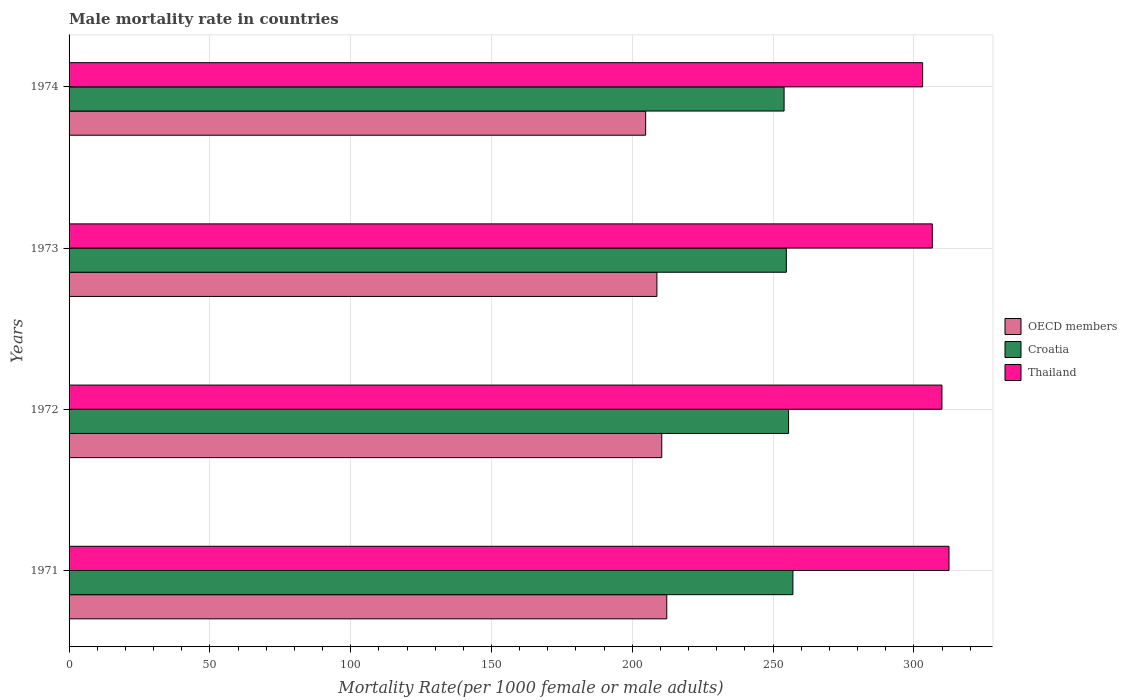How many different coloured bars are there?
Give a very brief answer. 3. Are the number of bars per tick equal to the number of legend labels?
Offer a terse response. Yes. What is the label of the 2nd group of bars from the top?
Your answer should be very brief. 1973. In how many cases, is the number of bars for a given year not equal to the number of legend labels?
Give a very brief answer. 0. What is the male mortality rate in OECD members in 1972?
Your answer should be very brief. 210.46. Across all years, what is the maximum male mortality rate in OECD members?
Keep it short and to the point. 212.24. Across all years, what is the minimum male mortality rate in Croatia?
Make the answer very short. 253.9. In which year was the male mortality rate in OECD members maximum?
Make the answer very short. 1971. In which year was the male mortality rate in OECD members minimum?
Offer a very short reply. 1974. What is the total male mortality rate in Croatia in the graph?
Your response must be concise. 1021.13. What is the difference between the male mortality rate in Croatia in 1973 and that in 1974?
Offer a terse response. 0.8. What is the difference between the male mortality rate in Croatia in 1974 and the male mortality rate in OECD members in 1972?
Provide a succinct answer. 43.44. What is the average male mortality rate in Croatia per year?
Your response must be concise. 255.28. In the year 1971, what is the difference between the male mortality rate in Thailand and male mortality rate in Croatia?
Keep it short and to the point. 55.42. In how many years, is the male mortality rate in Croatia greater than 90 ?
Ensure brevity in your answer.  4. What is the ratio of the male mortality rate in OECD members in 1972 to that in 1973?
Ensure brevity in your answer.  1.01. What is the difference between the highest and the second highest male mortality rate in OECD members?
Make the answer very short. 1.78. What is the difference between the highest and the lowest male mortality rate in OECD members?
Provide a short and direct response. 7.5. In how many years, is the male mortality rate in OECD members greater than the average male mortality rate in OECD members taken over all years?
Your response must be concise. 2. What does the 2nd bar from the top in 1974 represents?
Make the answer very short. Croatia. What does the 1st bar from the bottom in 1972 represents?
Offer a very short reply. OECD members. Are all the bars in the graph horizontal?
Provide a succinct answer. Yes. How many years are there in the graph?
Provide a succinct answer. 4. Are the values on the major ticks of X-axis written in scientific E-notation?
Provide a short and direct response. No. Where does the legend appear in the graph?
Your answer should be compact. Center right. How many legend labels are there?
Provide a succinct answer. 3. How are the legend labels stacked?
Give a very brief answer. Vertical. What is the title of the graph?
Offer a terse response. Male mortality rate in countries. What is the label or title of the X-axis?
Your answer should be compact. Mortality Rate(per 1000 female or male adults). What is the label or title of the Y-axis?
Offer a terse response. Years. What is the Mortality Rate(per 1000 female or male adults) of OECD members in 1971?
Your answer should be compact. 212.24. What is the Mortality Rate(per 1000 female or male adults) in Croatia in 1971?
Your response must be concise. 257.03. What is the Mortality Rate(per 1000 female or male adults) in Thailand in 1971?
Offer a very short reply. 312.46. What is the Mortality Rate(per 1000 female or male adults) of OECD members in 1972?
Make the answer very short. 210.46. What is the Mortality Rate(per 1000 female or male adults) of Croatia in 1972?
Your response must be concise. 255.5. What is the Mortality Rate(per 1000 female or male adults) of Thailand in 1972?
Provide a short and direct response. 309.95. What is the Mortality Rate(per 1000 female or male adults) of OECD members in 1973?
Offer a terse response. 208.74. What is the Mortality Rate(per 1000 female or male adults) of Croatia in 1973?
Make the answer very short. 254.7. What is the Mortality Rate(per 1000 female or male adults) in Thailand in 1973?
Provide a short and direct response. 306.52. What is the Mortality Rate(per 1000 female or male adults) in OECD members in 1974?
Provide a succinct answer. 204.74. What is the Mortality Rate(per 1000 female or male adults) in Croatia in 1974?
Offer a very short reply. 253.9. What is the Mortality Rate(per 1000 female or male adults) in Thailand in 1974?
Your response must be concise. 303.09. Across all years, what is the maximum Mortality Rate(per 1000 female or male adults) in OECD members?
Ensure brevity in your answer.  212.24. Across all years, what is the maximum Mortality Rate(per 1000 female or male adults) of Croatia?
Your response must be concise. 257.03. Across all years, what is the maximum Mortality Rate(per 1000 female or male adults) in Thailand?
Make the answer very short. 312.46. Across all years, what is the minimum Mortality Rate(per 1000 female or male adults) of OECD members?
Ensure brevity in your answer.  204.74. Across all years, what is the minimum Mortality Rate(per 1000 female or male adults) in Croatia?
Ensure brevity in your answer.  253.9. Across all years, what is the minimum Mortality Rate(per 1000 female or male adults) in Thailand?
Provide a short and direct response. 303.09. What is the total Mortality Rate(per 1000 female or male adults) of OECD members in the graph?
Offer a very short reply. 836.18. What is the total Mortality Rate(per 1000 female or male adults) in Croatia in the graph?
Ensure brevity in your answer.  1021.13. What is the total Mortality Rate(per 1000 female or male adults) of Thailand in the graph?
Make the answer very short. 1232.01. What is the difference between the Mortality Rate(per 1000 female or male adults) in OECD members in 1971 and that in 1972?
Give a very brief answer. 1.78. What is the difference between the Mortality Rate(per 1000 female or male adults) of Croatia in 1971 and that in 1972?
Give a very brief answer. 1.54. What is the difference between the Mortality Rate(per 1000 female or male adults) in Thailand in 1971 and that in 1972?
Ensure brevity in your answer.  2.51. What is the difference between the Mortality Rate(per 1000 female or male adults) of OECD members in 1971 and that in 1973?
Your response must be concise. 3.5. What is the difference between the Mortality Rate(per 1000 female or male adults) of Croatia in 1971 and that in 1973?
Your answer should be very brief. 2.34. What is the difference between the Mortality Rate(per 1000 female or male adults) in Thailand in 1971 and that in 1973?
Provide a short and direct response. 5.94. What is the difference between the Mortality Rate(per 1000 female or male adults) of OECD members in 1971 and that in 1974?
Your answer should be compact. 7.5. What is the difference between the Mortality Rate(per 1000 female or male adults) of Croatia in 1971 and that in 1974?
Your answer should be very brief. 3.13. What is the difference between the Mortality Rate(per 1000 female or male adults) of Thailand in 1971 and that in 1974?
Provide a short and direct response. 9.37. What is the difference between the Mortality Rate(per 1000 female or male adults) of OECD members in 1972 and that in 1973?
Provide a succinct answer. 1.72. What is the difference between the Mortality Rate(per 1000 female or male adults) in Croatia in 1972 and that in 1973?
Keep it short and to the point. 0.8. What is the difference between the Mortality Rate(per 1000 female or male adults) of Thailand in 1972 and that in 1973?
Provide a succinct answer. 3.43. What is the difference between the Mortality Rate(per 1000 female or male adults) of OECD members in 1972 and that in 1974?
Your response must be concise. 5.72. What is the difference between the Mortality Rate(per 1000 female or male adults) of Croatia in 1972 and that in 1974?
Your answer should be very brief. 1.59. What is the difference between the Mortality Rate(per 1000 female or male adults) of Thailand in 1972 and that in 1974?
Your response must be concise. 6.86. What is the difference between the Mortality Rate(per 1000 female or male adults) in OECD members in 1973 and that in 1974?
Give a very brief answer. 4. What is the difference between the Mortality Rate(per 1000 female or male adults) in Croatia in 1973 and that in 1974?
Make the answer very short. 0.8. What is the difference between the Mortality Rate(per 1000 female or male adults) of Thailand in 1973 and that in 1974?
Your response must be concise. 3.43. What is the difference between the Mortality Rate(per 1000 female or male adults) in OECD members in 1971 and the Mortality Rate(per 1000 female or male adults) in Croatia in 1972?
Provide a short and direct response. -43.25. What is the difference between the Mortality Rate(per 1000 female or male adults) in OECD members in 1971 and the Mortality Rate(per 1000 female or male adults) in Thailand in 1972?
Make the answer very short. -97.7. What is the difference between the Mortality Rate(per 1000 female or male adults) of Croatia in 1971 and the Mortality Rate(per 1000 female or male adults) of Thailand in 1972?
Provide a succinct answer. -52.91. What is the difference between the Mortality Rate(per 1000 female or male adults) in OECD members in 1971 and the Mortality Rate(per 1000 female or male adults) in Croatia in 1973?
Offer a terse response. -42.46. What is the difference between the Mortality Rate(per 1000 female or male adults) in OECD members in 1971 and the Mortality Rate(per 1000 female or male adults) in Thailand in 1973?
Offer a terse response. -94.28. What is the difference between the Mortality Rate(per 1000 female or male adults) of Croatia in 1971 and the Mortality Rate(per 1000 female or male adults) of Thailand in 1973?
Your answer should be very brief. -49.48. What is the difference between the Mortality Rate(per 1000 female or male adults) in OECD members in 1971 and the Mortality Rate(per 1000 female or male adults) in Croatia in 1974?
Give a very brief answer. -41.66. What is the difference between the Mortality Rate(per 1000 female or male adults) in OECD members in 1971 and the Mortality Rate(per 1000 female or male adults) in Thailand in 1974?
Keep it short and to the point. -90.85. What is the difference between the Mortality Rate(per 1000 female or male adults) in Croatia in 1971 and the Mortality Rate(per 1000 female or male adults) in Thailand in 1974?
Provide a short and direct response. -46.06. What is the difference between the Mortality Rate(per 1000 female or male adults) of OECD members in 1972 and the Mortality Rate(per 1000 female or male adults) of Croatia in 1973?
Give a very brief answer. -44.24. What is the difference between the Mortality Rate(per 1000 female or male adults) in OECD members in 1972 and the Mortality Rate(per 1000 female or male adults) in Thailand in 1973?
Make the answer very short. -96.06. What is the difference between the Mortality Rate(per 1000 female or male adults) of Croatia in 1972 and the Mortality Rate(per 1000 female or male adults) of Thailand in 1973?
Ensure brevity in your answer.  -51.02. What is the difference between the Mortality Rate(per 1000 female or male adults) of OECD members in 1972 and the Mortality Rate(per 1000 female or male adults) of Croatia in 1974?
Your answer should be compact. -43.44. What is the difference between the Mortality Rate(per 1000 female or male adults) in OECD members in 1972 and the Mortality Rate(per 1000 female or male adults) in Thailand in 1974?
Your answer should be compact. -92.63. What is the difference between the Mortality Rate(per 1000 female or male adults) in Croatia in 1972 and the Mortality Rate(per 1000 female or male adults) in Thailand in 1974?
Make the answer very short. -47.59. What is the difference between the Mortality Rate(per 1000 female or male adults) of OECD members in 1973 and the Mortality Rate(per 1000 female or male adults) of Croatia in 1974?
Offer a very short reply. -45.16. What is the difference between the Mortality Rate(per 1000 female or male adults) in OECD members in 1973 and the Mortality Rate(per 1000 female or male adults) in Thailand in 1974?
Your answer should be very brief. -94.35. What is the difference between the Mortality Rate(per 1000 female or male adults) of Croatia in 1973 and the Mortality Rate(per 1000 female or male adults) of Thailand in 1974?
Keep it short and to the point. -48.39. What is the average Mortality Rate(per 1000 female or male adults) in OECD members per year?
Provide a short and direct response. 209.05. What is the average Mortality Rate(per 1000 female or male adults) of Croatia per year?
Offer a terse response. 255.28. What is the average Mortality Rate(per 1000 female or male adults) in Thailand per year?
Provide a short and direct response. 308. In the year 1971, what is the difference between the Mortality Rate(per 1000 female or male adults) of OECD members and Mortality Rate(per 1000 female or male adults) of Croatia?
Your answer should be compact. -44.79. In the year 1971, what is the difference between the Mortality Rate(per 1000 female or male adults) of OECD members and Mortality Rate(per 1000 female or male adults) of Thailand?
Your answer should be compact. -100.21. In the year 1971, what is the difference between the Mortality Rate(per 1000 female or male adults) in Croatia and Mortality Rate(per 1000 female or male adults) in Thailand?
Keep it short and to the point. -55.42. In the year 1972, what is the difference between the Mortality Rate(per 1000 female or male adults) of OECD members and Mortality Rate(per 1000 female or male adults) of Croatia?
Give a very brief answer. -45.03. In the year 1972, what is the difference between the Mortality Rate(per 1000 female or male adults) in OECD members and Mortality Rate(per 1000 female or male adults) in Thailand?
Give a very brief answer. -99.48. In the year 1972, what is the difference between the Mortality Rate(per 1000 female or male adults) of Croatia and Mortality Rate(per 1000 female or male adults) of Thailand?
Give a very brief answer. -54.45. In the year 1973, what is the difference between the Mortality Rate(per 1000 female or male adults) of OECD members and Mortality Rate(per 1000 female or male adults) of Croatia?
Keep it short and to the point. -45.96. In the year 1973, what is the difference between the Mortality Rate(per 1000 female or male adults) of OECD members and Mortality Rate(per 1000 female or male adults) of Thailand?
Make the answer very short. -97.78. In the year 1973, what is the difference between the Mortality Rate(per 1000 female or male adults) of Croatia and Mortality Rate(per 1000 female or male adults) of Thailand?
Your answer should be very brief. -51.82. In the year 1974, what is the difference between the Mortality Rate(per 1000 female or male adults) in OECD members and Mortality Rate(per 1000 female or male adults) in Croatia?
Provide a short and direct response. -49.16. In the year 1974, what is the difference between the Mortality Rate(per 1000 female or male adults) in OECD members and Mortality Rate(per 1000 female or male adults) in Thailand?
Ensure brevity in your answer.  -98.35. In the year 1974, what is the difference between the Mortality Rate(per 1000 female or male adults) of Croatia and Mortality Rate(per 1000 female or male adults) of Thailand?
Offer a very short reply. -49.19. What is the ratio of the Mortality Rate(per 1000 female or male adults) of OECD members in 1971 to that in 1972?
Offer a very short reply. 1.01. What is the ratio of the Mortality Rate(per 1000 female or male adults) in Croatia in 1971 to that in 1972?
Keep it short and to the point. 1.01. What is the ratio of the Mortality Rate(per 1000 female or male adults) in Thailand in 1971 to that in 1972?
Ensure brevity in your answer.  1.01. What is the ratio of the Mortality Rate(per 1000 female or male adults) of OECD members in 1971 to that in 1973?
Provide a short and direct response. 1.02. What is the ratio of the Mortality Rate(per 1000 female or male adults) of Croatia in 1971 to that in 1973?
Offer a terse response. 1.01. What is the ratio of the Mortality Rate(per 1000 female or male adults) in Thailand in 1971 to that in 1973?
Make the answer very short. 1.02. What is the ratio of the Mortality Rate(per 1000 female or male adults) in OECD members in 1971 to that in 1974?
Provide a succinct answer. 1.04. What is the ratio of the Mortality Rate(per 1000 female or male adults) in Croatia in 1971 to that in 1974?
Ensure brevity in your answer.  1.01. What is the ratio of the Mortality Rate(per 1000 female or male adults) of Thailand in 1971 to that in 1974?
Your answer should be compact. 1.03. What is the ratio of the Mortality Rate(per 1000 female or male adults) in OECD members in 1972 to that in 1973?
Ensure brevity in your answer.  1.01. What is the ratio of the Mortality Rate(per 1000 female or male adults) in Thailand in 1972 to that in 1973?
Provide a succinct answer. 1.01. What is the ratio of the Mortality Rate(per 1000 female or male adults) in OECD members in 1972 to that in 1974?
Offer a terse response. 1.03. What is the ratio of the Mortality Rate(per 1000 female or male adults) in Thailand in 1972 to that in 1974?
Give a very brief answer. 1.02. What is the ratio of the Mortality Rate(per 1000 female or male adults) in OECD members in 1973 to that in 1974?
Provide a succinct answer. 1.02. What is the ratio of the Mortality Rate(per 1000 female or male adults) in Thailand in 1973 to that in 1974?
Keep it short and to the point. 1.01. What is the difference between the highest and the second highest Mortality Rate(per 1000 female or male adults) in OECD members?
Provide a succinct answer. 1.78. What is the difference between the highest and the second highest Mortality Rate(per 1000 female or male adults) of Croatia?
Ensure brevity in your answer.  1.54. What is the difference between the highest and the second highest Mortality Rate(per 1000 female or male adults) of Thailand?
Offer a terse response. 2.51. What is the difference between the highest and the lowest Mortality Rate(per 1000 female or male adults) of OECD members?
Offer a very short reply. 7.5. What is the difference between the highest and the lowest Mortality Rate(per 1000 female or male adults) of Croatia?
Your answer should be compact. 3.13. What is the difference between the highest and the lowest Mortality Rate(per 1000 female or male adults) of Thailand?
Your response must be concise. 9.37. 